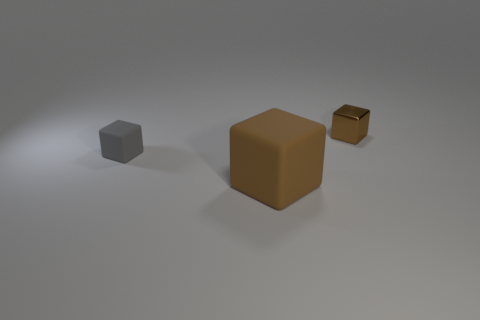Is there anything else that has the same size as the brown rubber thing?
Offer a very short reply. No. What shape is the other large object that is the same color as the metallic object?
Offer a very short reply. Cube. What is the size of the gray rubber object that is the same shape as the tiny shiny thing?
Ensure brevity in your answer.  Small. There is a tiny thing that is behind the small rubber cube; is its shape the same as the small gray matte object?
Offer a terse response. Yes. There is a tiny thing that is in front of the metallic thing; what color is it?
Your answer should be very brief. Gray. How many other things are there of the same size as the brown matte object?
Offer a very short reply. 0. Are there any other things that have the same shape as the gray rubber object?
Give a very brief answer. Yes. Is the number of brown rubber objects that are behind the tiny shiny thing the same as the number of small brown metal cubes?
Offer a terse response. No. How many objects are made of the same material as the small brown cube?
Your answer should be very brief. 0. What color is the other thing that is made of the same material as the gray thing?
Give a very brief answer. Brown. 